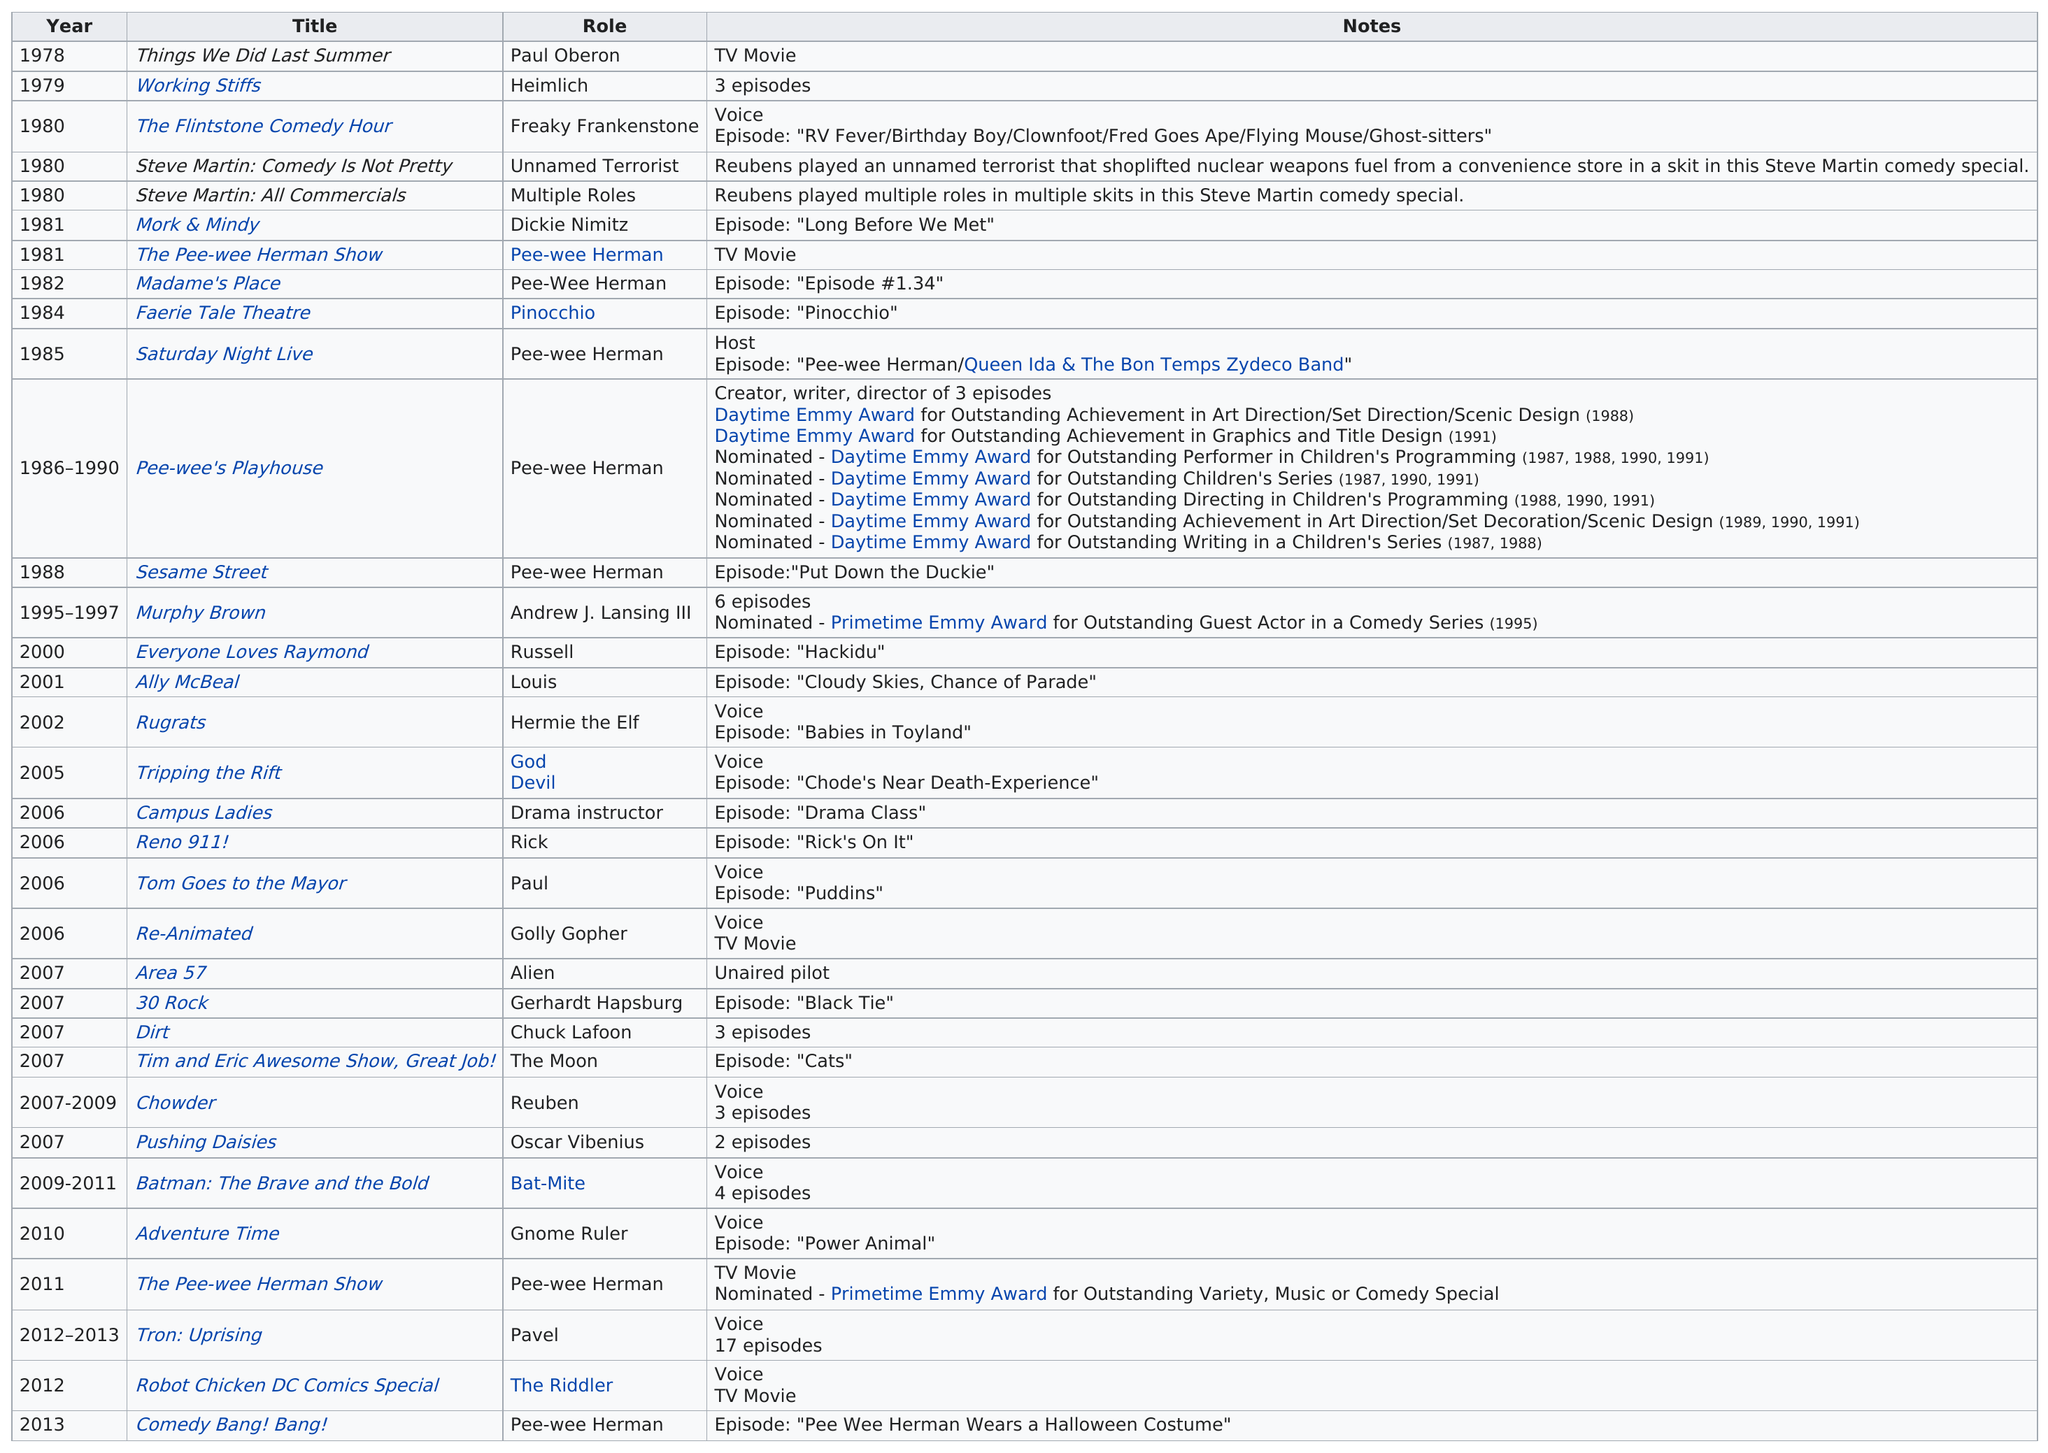Outline some significant characteristics in this image. The name of Paul Reubens' character in the popular T.V. show "Murphy Brown" was Andrew J. Lansing III. Pee-wee's Playhouse ran on television for a total of four years from 1986 to 1990. 